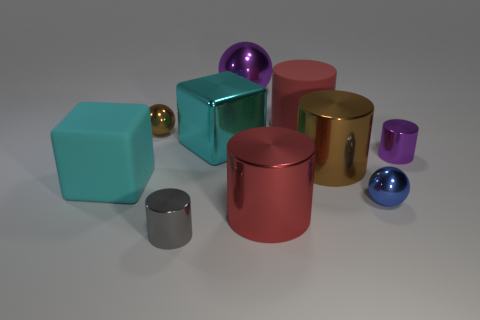Is the big matte block the same color as the large metal cube?
Your response must be concise. Yes. What number of metallic things are either large red cylinders or yellow cylinders?
Ensure brevity in your answer.  1. There is a shiny cylinder that is both left of the blue metallic object and behind the red metallic object; how big is it?
Your answer should be compact. Large. Are there any cyan objects in front of the large cyan thing that is behind the small purple shiny cylinder?
Your response must be concise. Yes. There is a small gray cylinder; what number of spheres are left of it?
Make the answer very short. 1. What is the color of the other small shiny thing that is the same shape as the gray shiny thing?
Make the answer very short. Purple. Are the tiny cylinder that is in front of the big matte block and the red thing that is behind the red metallic cylinder made of the same material?
Your answer should be compact. No. Do the big metallic ball and the shiny cylinder on the right side of the large brown cylinder have the same color?
Provide a succinct answer. Yes. What shape is the small thing that is both behind the red metal object and left of the large purple metallic sphere?
Offer a terse response. Sphere. What number of large cyan rubber objects are there?
Keep it short and to the point. 1. 